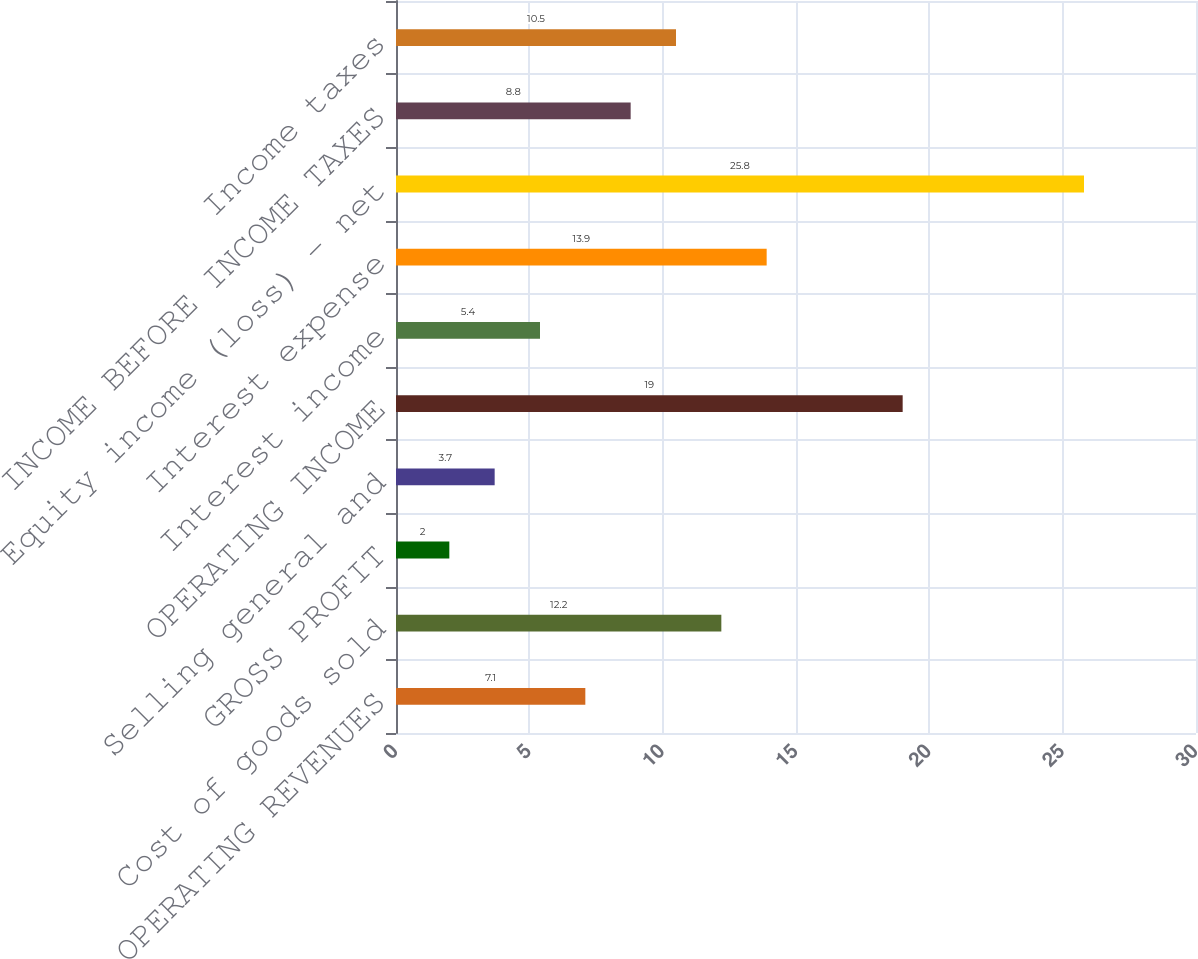<chart> <loc_0><loc_0><loc_500><loc_500><bar_chart><fcel>NET OPERATING REVENUES<fcel>Cost of goods sold<fcel>GROSS PROFIT<fcel>Selling general and<fcel>OPERATING INCOME<fcel>Interest income<fcel>Interest expense<fcel>Equity income (loss) - net<fcel>INCOME BEFORE INCOME TAXES<fcel>Income taxes<nl><fcel>7.1<fcel>12.2<fcel>2<fcel>3.7<fcel>19<fcel>5.4<fcel>13.9<fcel>25.8<fcel>8.8<fcel>10.5<nl></chart> 